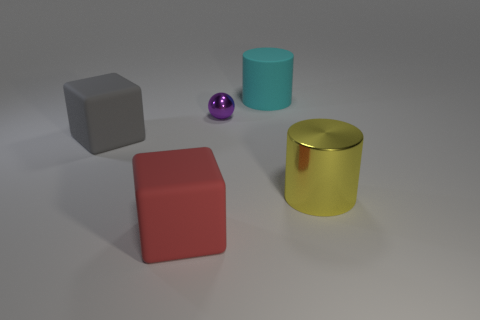Are there an equal number of cyan matte things that are on the left side of the large gray rubber thing and cyan rubber things?
Ensure brevity in your answer.  No. Are there any cylinders to the left of the large gray cube?
Your response must be concise. No. Is the shape of the purple metallic object the same as the rubber object that is in front of the yellow thing?
Provide a succinct answer. No. There is a large cylinder that is the same material as the sphere; what is its color?
Make the answer very short. Yellow. Are there an equal number of large gray objects and tiny green shiny cylinders?
Your answer should be very brief. No. The shiny ball has what color?
Offer a very short reply. Purple. Are the big gray object and the cylinder that is to the right of the large cyan matte object made of the same material?
Offer a terse response. No. What number of large objects are both on the right side of the big cyan matte thing and in front of the big yellow shiny cylinder?
Your response must be concise. 0. The yellow thing that is the same size as the cyan rubber cylinder is what shape?
Your answer should be compact. Cylinder. There is a thing behind the shiny object on the left side of the big cyan cylinder; are there any gray matte objects that are behind it?
Your answer should be very brief. No. 